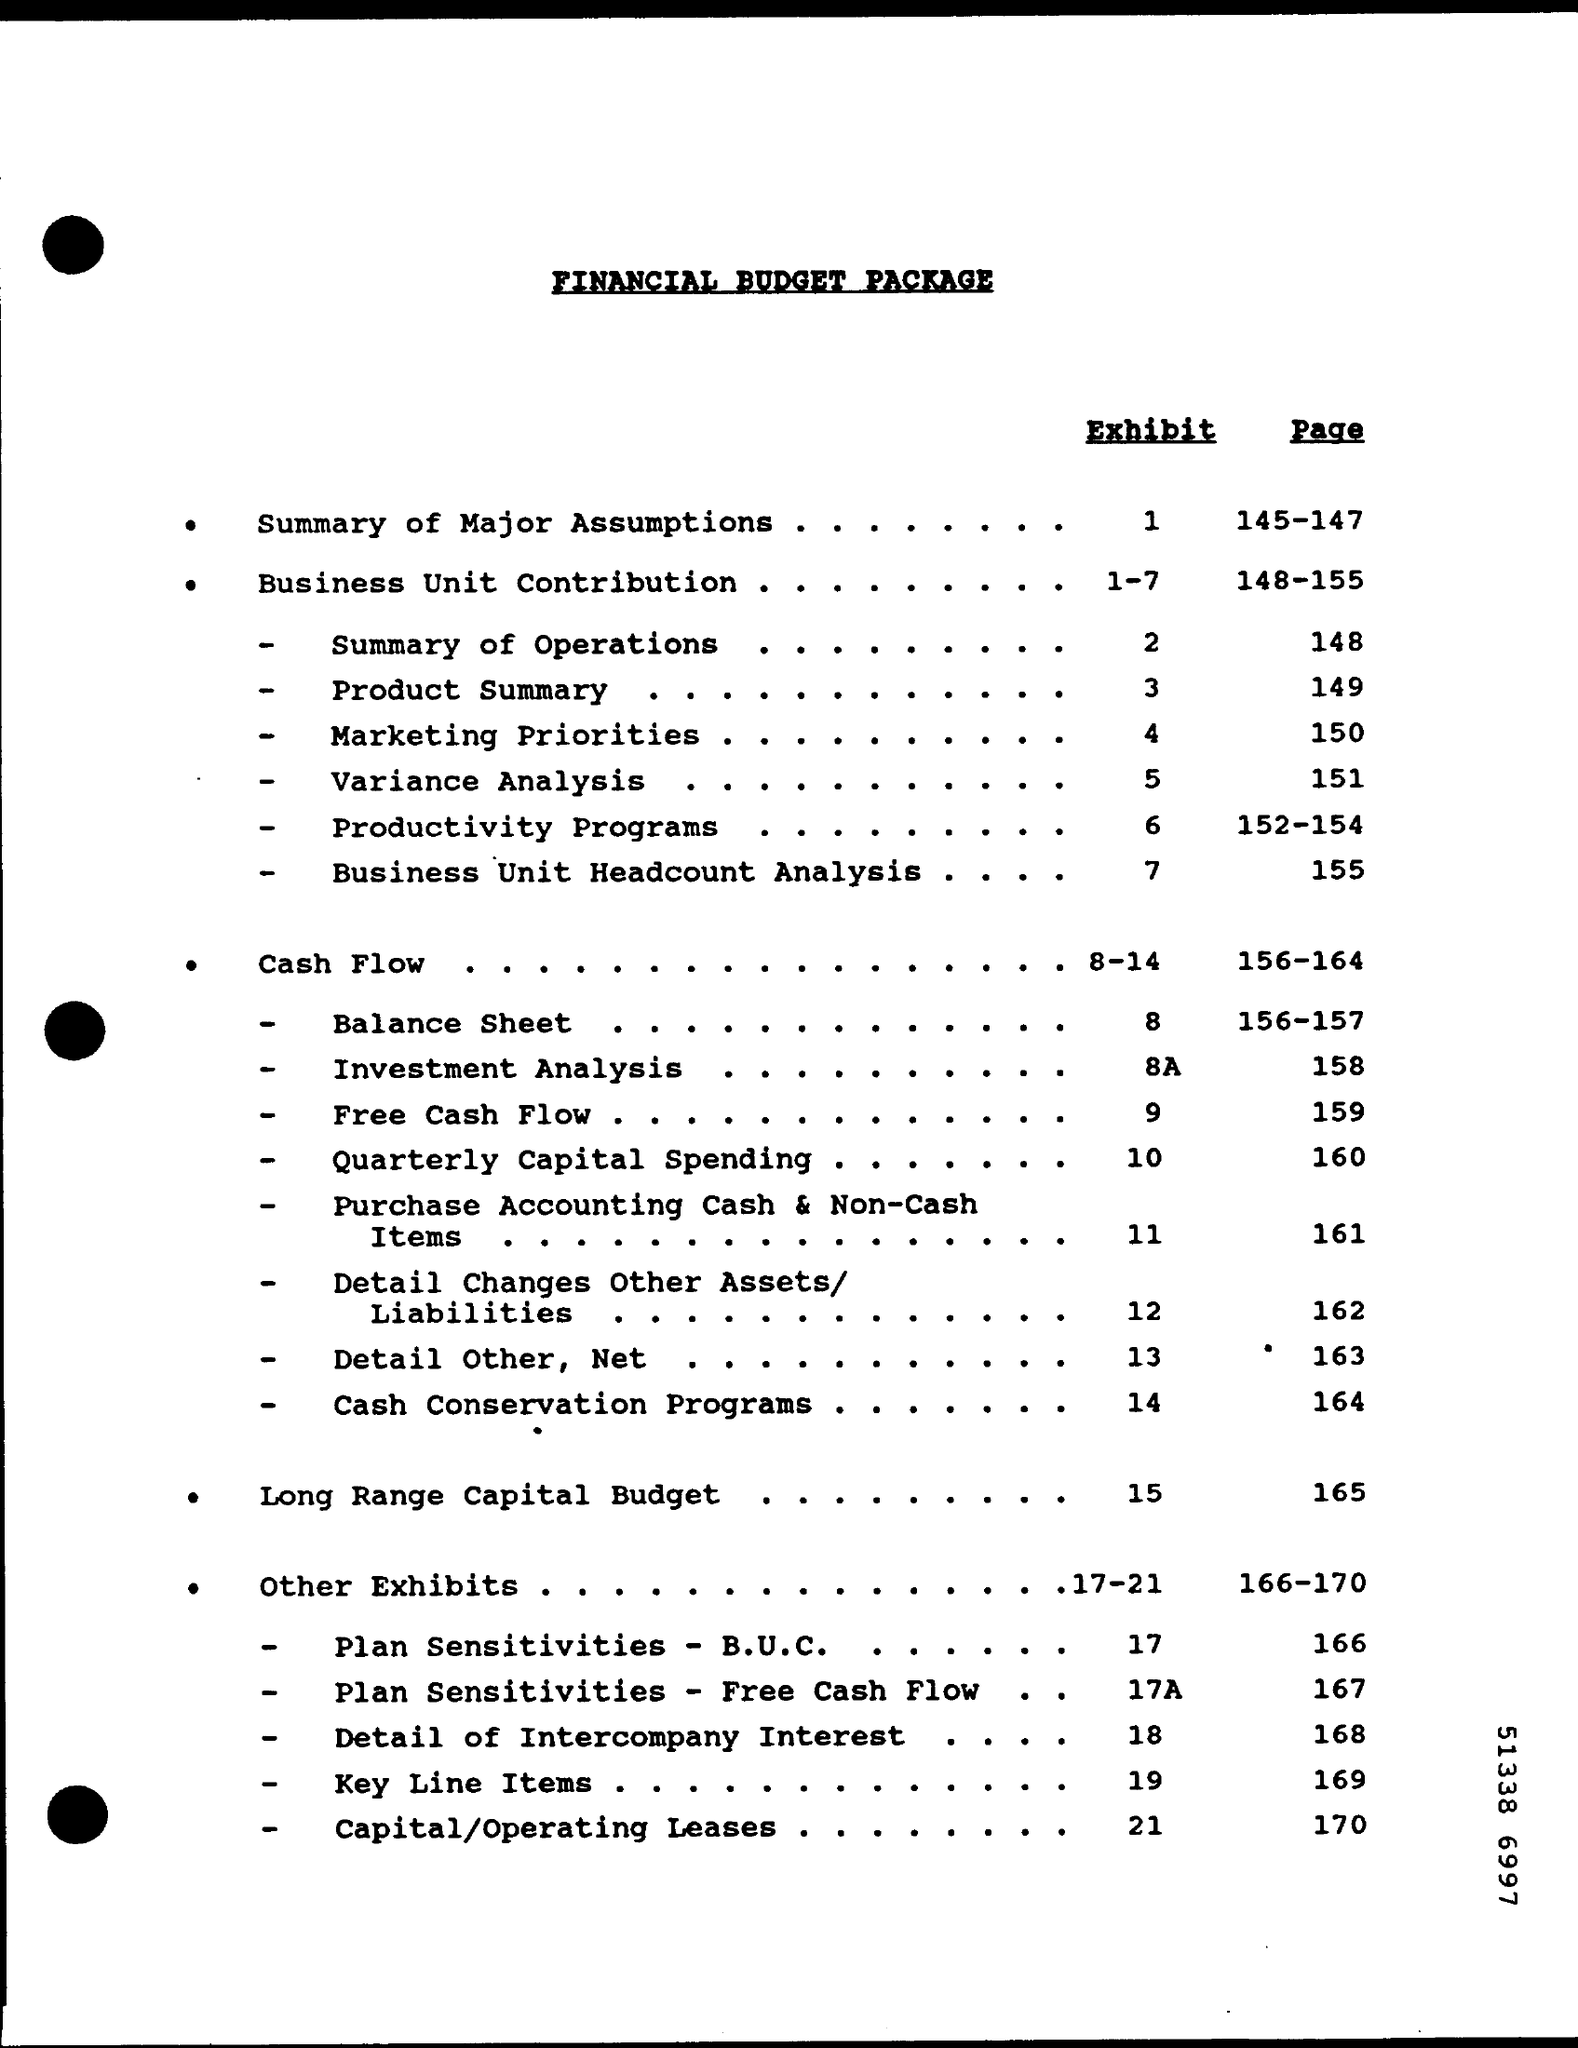In which page balance sheet is given ?
Your response must be concise. 156-157. In which page summary of major assumptions  is given ?
Make the answer very short. 145-147. In which page long range capital budget  is given ?
Ensure brevity in your answer.  165. What is the exhibit no for summary of major assumptions ?
Offer a terse response. 1. What is the exhibit no for other exhibits
Your answer should be very brief. 17-21. In which page other exhibits is mentioned ?
Your answer should be compact. 166-170. What is the exhibit for business unit contribution ?
Your answer should be very brief. 1-7. 